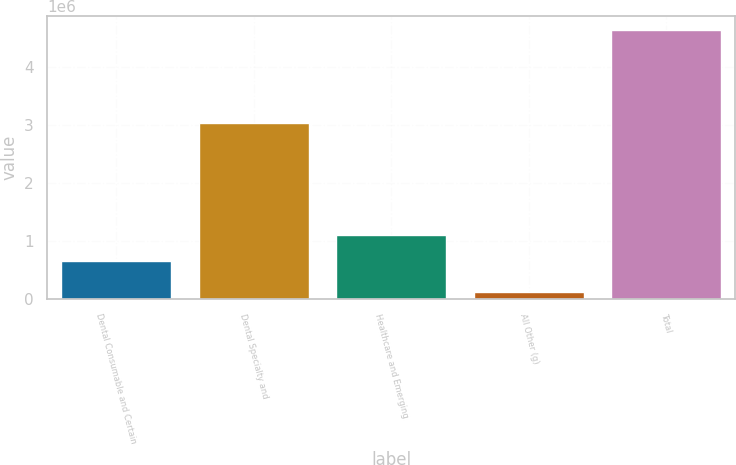Convert chart to OTSL. <chart><loc_0><loc_0><loc_500><loc_500><bar_chart><fcel>Dental Consumable and Certain<fcel>Dental Specialty and<fcel>Healthcare and Emerging<fcel>All Other (g)<fcel>Total<nl><fcel>661260<fcel>3.03798e+06<fcel>1.11341e+06<fcel>128789<fcel>4.65026e+06<nl></chart> 